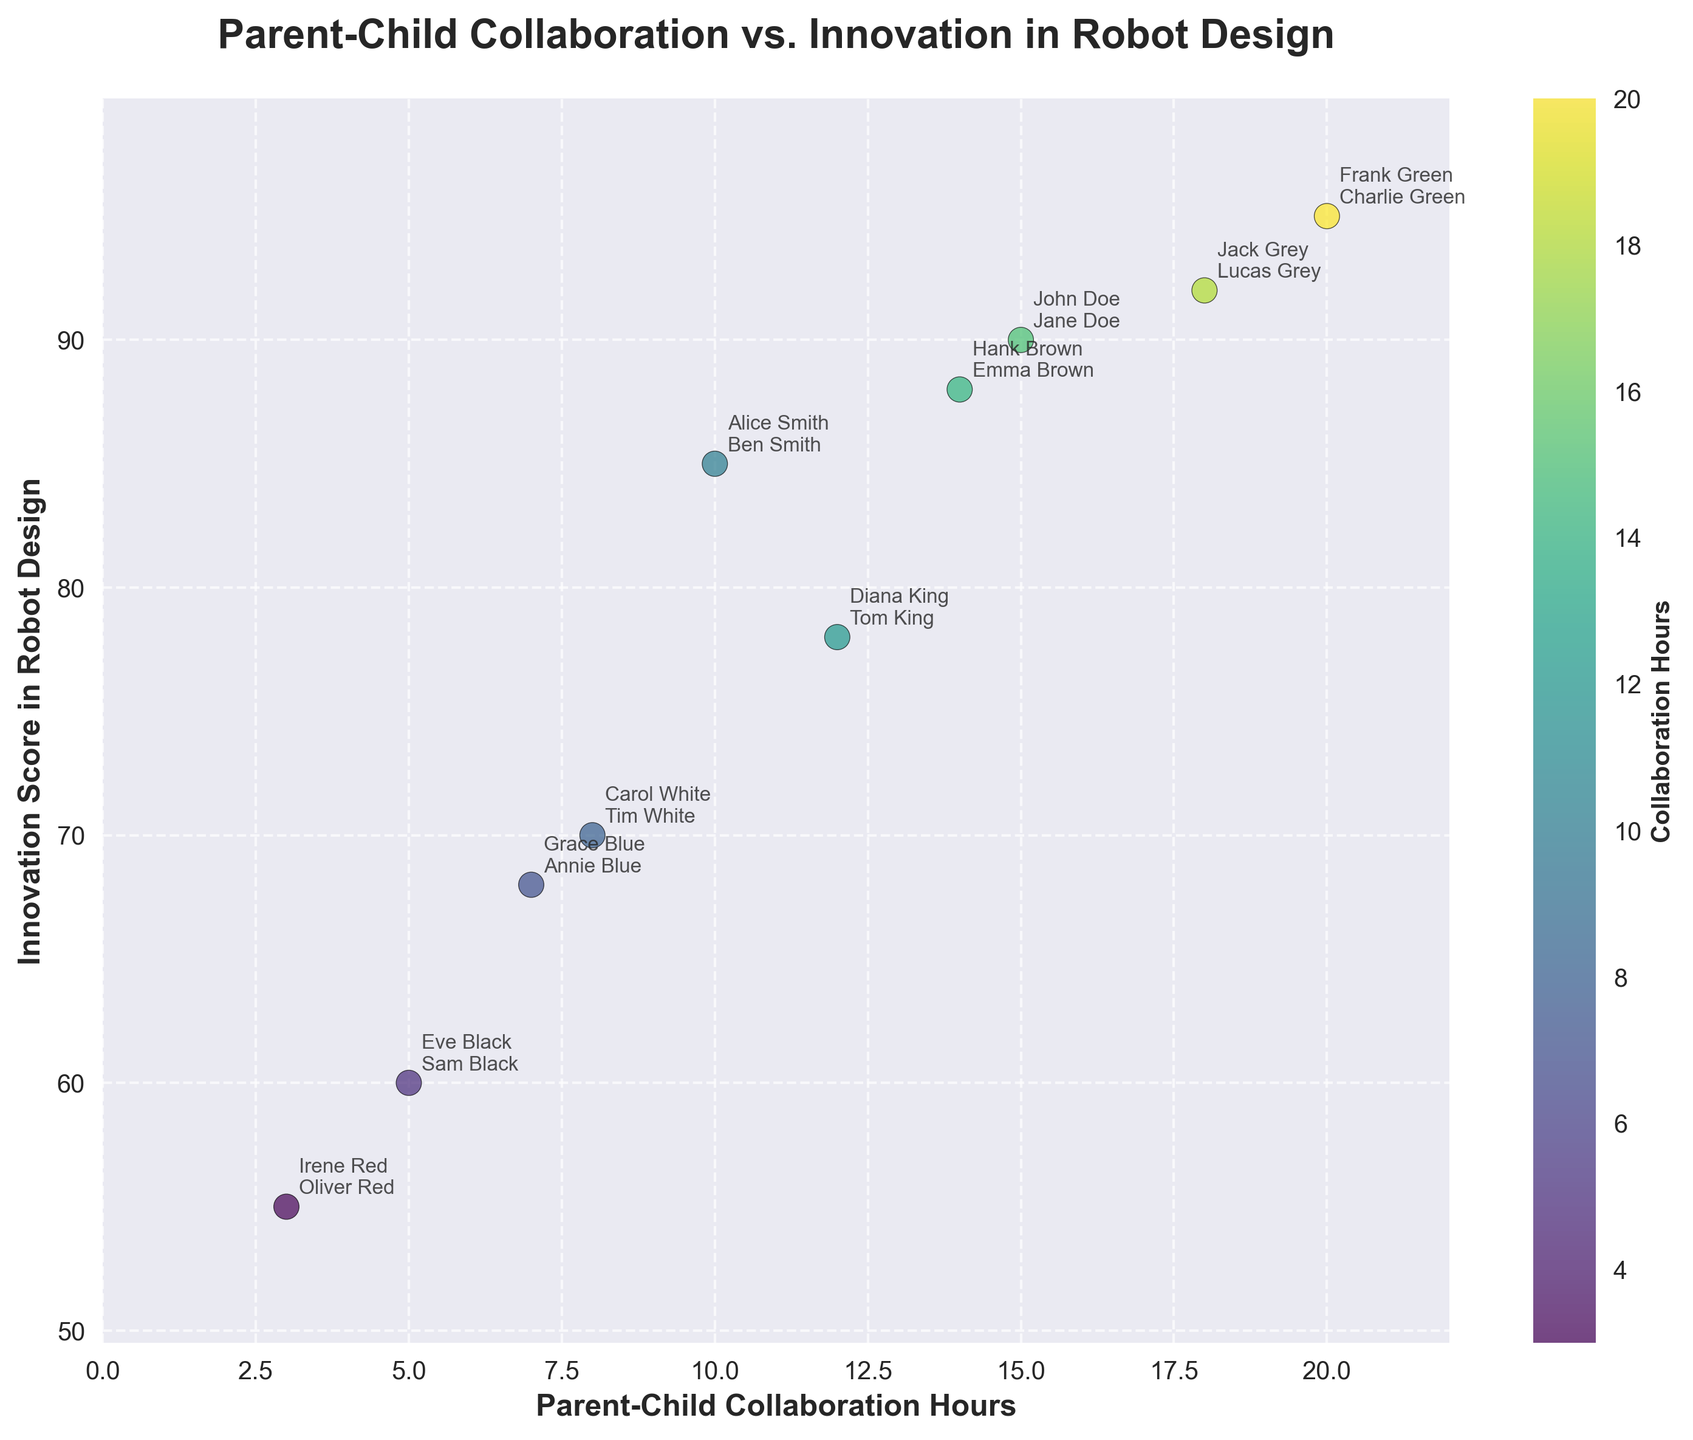What is the title of the scatter plot? The title is found at the top of the scatter plot. It indicates the main focus of the visualization.
Answer: Parent-Child Collaboration vs. Innovation in Robot Design How many data points are shown in the scatter plot? By counting the number of distinct markers (dots) in the scatter plot, you can determine the number of data points.
Answer: 10 What does the color of the dots represent in the scatter plot? The color of the dots is encoded with collaboration hours, which is evident from the colorbar that labels 'Collaboration Hours'.
Answer: Collaboration Hours Which parent-child pair has the highest collaboration hours and what is their innovation score? The point representing the highest collaboration hours can be identified through the color intensity or the annotation. Here, Frank Green and Charlie Green, at 20 hours, represent the highest collaboration hours. Their innovation score is annotated next to the dot.
Answer: Frank Green and Charlie Green, 95 What is the collaboration hours range on the x-axis? The collaboration hours range can be seen on the x-axis from the minimum to the maximum value shown, excluding minor gridlines.
Answer: 0 to 22 (approximately) Which parent-child pair has the lowest innovation score and how many collaboration hours do they have? The point at the lowest position on the y-axis represents the lowest innovation score. The annotation next to it indicates that Irene Red and Oliver Red have the lowest score. Their collaboration hours can be found on the x-axis.
Answer: Irene Red and Oliver Red, 55 Is there a general trend between collaboration hours and innovation score? Observing the scatter plot’s distribution, points with higher collaboration hours tend to have higher innovation scores, indicating a positive correlation.
Answer: Positive correlation Compare the innovation scores of Diana King and Tom King with Hank Brown and Emma Brown, and state which is higher. Locate the points for each pair and compare their positions on the y-axis. Hank Brown and Emma Brown have an innovation score of 88, higher than Diana King and Tom King's score of 78.
Answer: Hank Brown and Emma Brown, 88 Calculate the average innovation score for all data points in the plot. Sum all the innovation scores (85 + 90 + 70 + 78 + 60 + 95 + 68 + 88 + 55 + 92) = 781, then divide by the number of data points (10). The average score is 781 / 10.
Answer: 78.1 